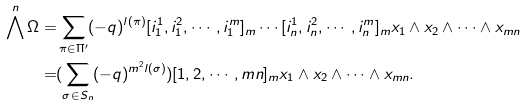Convert formula to latex. <formula><loc_0><loc_0><loc_500><loc_500>\bigwedge ^ { n } \Omega = & \sum _ { \pi \in \Pi ^ { \prime } } ( - q ) ^ { l ( \pi ) } [ i _ { 1 } ^ { 1 } , i _ { 1 } ^ { 2 } , \cdots , i _ { 1 } ^ { m } ] _ { m } \cdots [ i _ { n } ^ { 1 } , i _ { n } ^ { 2 } , \cdots , i _ { n } ^ { m } ] _ { m } x _ { 1 } \wedge x _ { 2 } \wedge \cdots \wedge x _ { m n } \\ = & ( { \sum _ { \sigma \in S _ { n } } ( - q ) ^ { m ^ { 2 } l ( \sigma ) } } ) [ 1 , 2 , \cdots , m n ] _ { m } x _ { 1 } \wedge x _ { 2 } \wedge \cdots \wedge x _ { m n } .</formula> 